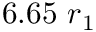<formula> <loc_0><loc_0><loc_500><loc_500>6 . 6 5 r _ { 1 }</formula> 